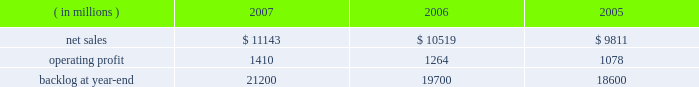Air mobility sales declined by $ 535 million primarily due to c-130j deliveries ( 12 in 2006 compared to 15 in 2005 ) and lower volume on the c-5 program .
Combat aircraft sales increased by $ 292 million mainly due to higher f-35 and f-22 volume , partially offset by reduced volume on f-16 programs .
Other aeronautics programs sales increased by $ 83 million primarily due to higher volume in sustainment services activities .
Operating profit for the segment increased 21% ( 21 % ) in 2007 compared to 2006 .
Operating profit increases in combat aircraft more than offset decreases in other aeronautics programs and air mobility .
Combat aircraft operating profit increased $ 326 million mainly due to improved performance on f-22 and f-16 programs .
Air mobility and other aeronautics programs declined $ 77 million due to lower operating profit in support and sustainment activities .
Operating profit for the segment increased 20% ( 20 % ) in 2006 compared to 2005 .
Operating profit increased in both combat aircraft and air mobility .
Combat aircraft increased $ 114 million , mainly due to higher volume on the f-35 and f-22 programs , and improved performance on f-16 programs .
The improvement for the year was also attributable in part to the fact that in 2005 , operating profit included a reduction in earnings on the f-35 program .
Air mobility operating profit increased $ 84 million , mainly due to improved performance on c-130j sustainment activities in 2006 .
Backlog decreased in 2007 as compared to 2006 primarily as a result of sales volume on the f-35 program .
This decrease was offset partially by increased orders on the f-22 and c-130j programs .
Electronic systems electronic systems 2019 operating results included the following : ( in millions ) 2007 2006 2005 .
Net sales for electronic systems increased by 6% ( 6 % ) in 2007 compared to 2006 .
Sales increased in missiles & fire control ( m&fc ) , maritime systems & sensors ( ms2 ) , and platform , training & energy ( pt&e ) .
M&fc sales increased $ 258 million mainly due to higher volume in fire control systems and air defense programs , which more than offset declines in tactical missile programs .
Ms2 sales grew $ 254 million due to volume increases in undersea and radar systems activities that were offset partially by decreases in surface systems activities .
Pt&e sales increased $ 113 million , primarily due to higher volume in platform integration activities , which more than offset declines in distribution technology activities .
Net sales for electronic systems increased by 7% ( 7 % ) in 2006 compared to 2005 .
Higher volume in platform integration activities led to increased sales of $ 329 million at pt&e .
Ms2 sales increased $ 267 million primarily due to surface systems activities .
Air defense programs contributed to increased sales of $ 118 million at m&fc .
Operating profit for the segment increased by 12% ( 12 % ) in 2007 compared to 2006 , representing an increase in all three lines of business during the year .
Operating profit increased $ 70 million at pt&e primarily due to higher volume and improved performance on platform integration activities .
Ms2 operating profit increased $ 32 million due to higher volume on undersea and tactical systems activities that more than offset lower volume on surface systems activities .
At m&fc , operating profit increased $ 32 million due to higher volume in fire control systems and improved performance in tactical missile programs , which partially were offset by performance on certain international air defense programs in 2006 .
Operating profit for the segment increased by 17% ( 17 % ) in 2006 compared to 2005 .
Operating profit increased by $ 74 million at ms2 mainly due to higher volume on surface systems and undersea programs .
Pt&e operating profit increased $ 61 million mainly due to improved performance on distribution technology activities .
Higher volume on air defense programs contributed to a $ 52 million increase in operating profit at m&fc .
The increase in backlog during 2007 over 2006 resulted primarily from increased orders for certain tactical missile programs and fire control systems at m&fc and platform integration programs at pt&e. .
What was the percentage change in backlog from 2006 to 2007? 
Computations: ((21200 - 19700) / 19700)
Answer: 0.07614. 